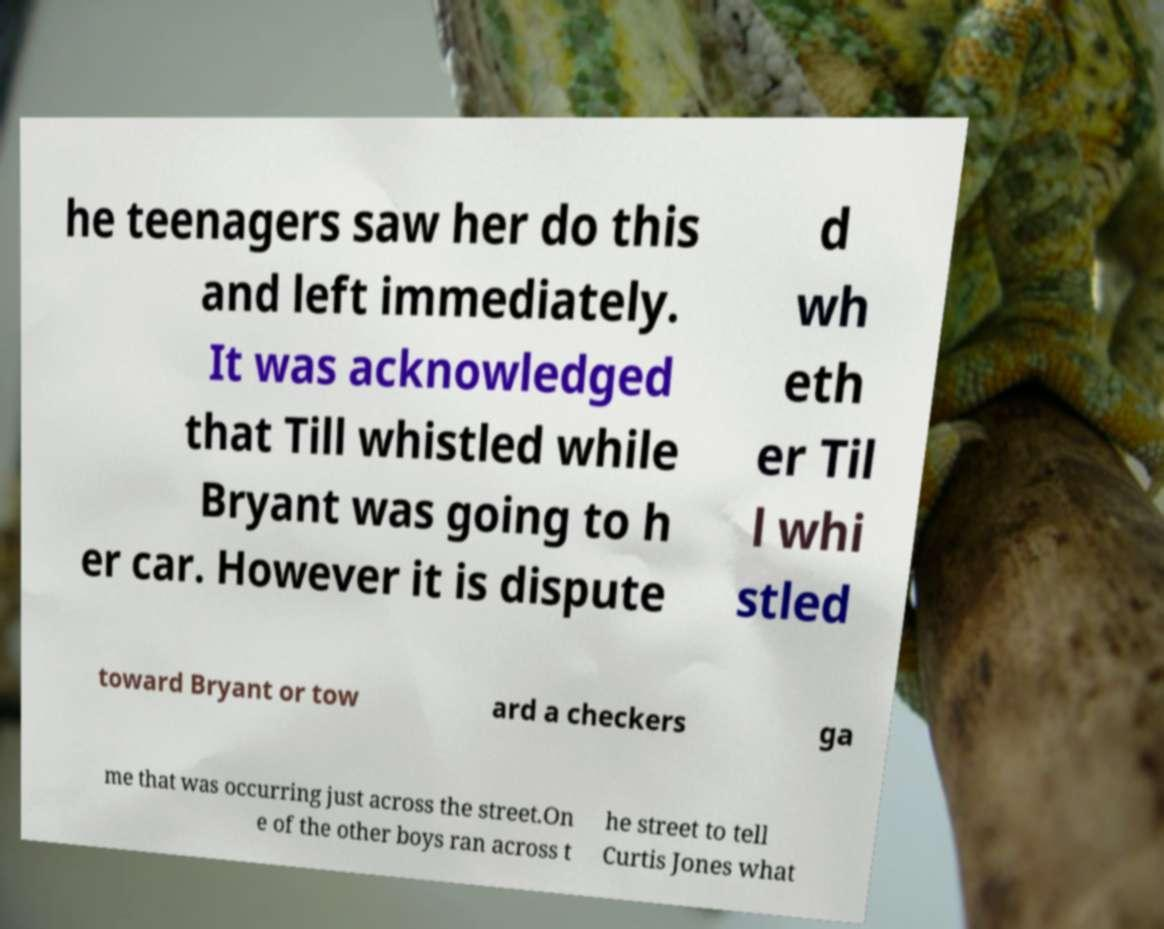What messages or text are displayed in this image? I need them in a readable, typed format. he teenagers saw her do this and left immediately. It was acknowledged that Till whistled while Bryant was going to h er car. However it is dispute d wh eth er Til l whi stled toward Bryant or tow ard a checkers ga me that was occurring just across the street.On e of the other boys ran across t he street to tell Curtis Jones what 